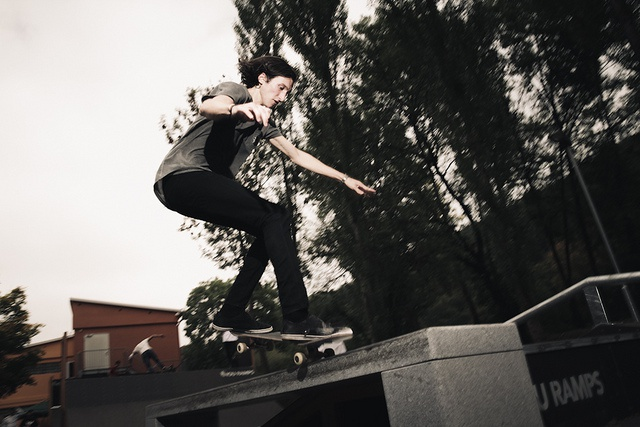Describe the objects in this image and their specific colors. I can see people in lightgray, black, gray, and darkgray tones, bench in lightgray, gray, black, and darkgray tones, skateboard in lightgray, black, gray, and darkgray tones, people in lightgray, black, maroon, gray, and darkgray tones, and people in black and lightgray tones in this image. 